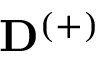Convert formula to latex. <formula><loc_0><loc_0><loc_500><loc_500>D ^ { ( + ) }</formula> 